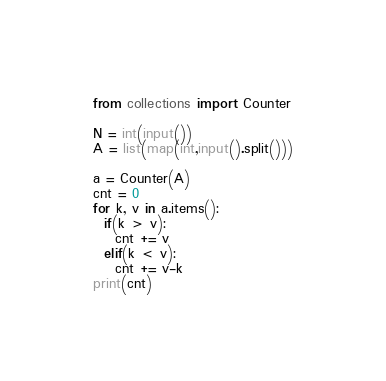<code> <loc_0><loc_0><loc_500><loc_500><_Python_>from collections import Counter

N = int(input())
A = list(map(int,input().split()))

a = Counter(A)
cnt = 0
for k, v in a.items():
  if(k > v):
    cnt += v
  elif(k < v):
    cnt += v-k
print(cnt)</code> 